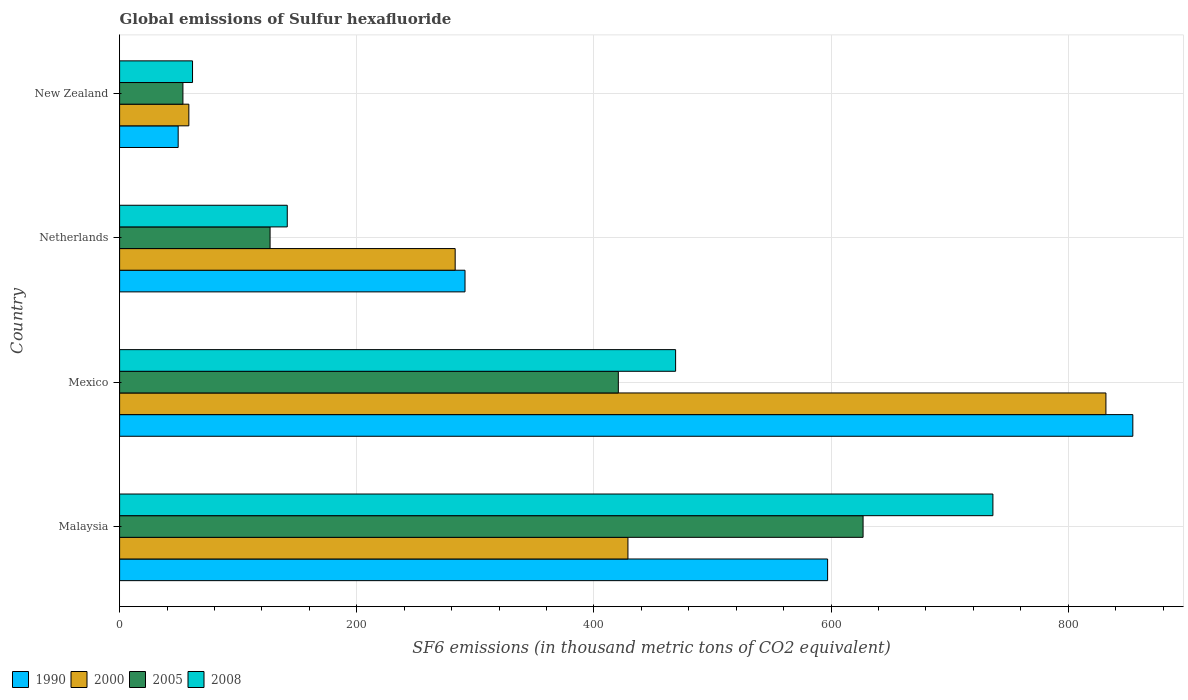How many different coloured bars are there?
Provide a short and direct response. 4. How many groups of bars are there?
Your answer should be compact. 4. How many bars are there on the 3rd tick from the top?
Keep it short and to the point. 4. How many bars are there on the 3rd tick from the bottom?
Keep it short and to the point. 4. What is the label of the 4th group of bars from the top?
Give a very brief answer. Malaysia. What is the global emissions of Sulfur hexafluoride in 1990 in Mexico?
Your answer should be very brief. 854.5. Across all countries, what is the maximum global emissions of Sulfur hexafluoride in 2005?
Your answer should be compact. 627. Across all countries, what is the minimum global emissions of Sulfur hexafluoride in 2008?
Make the answer very short. 61.5. In which country was the global emissions of Sulfur hexafluoride in 2008 maximum?
Your answer should be compact. Malaysia. In which country was the global emissions of Sulfur hexafluoride in 2005 minimum?
Give a very brief answer. New Zealand. What is the total global emissions of Sulfur hexafluoride in 2005 in the graph?
Offer a very short reply. 1227.9. What is the difference between the global emissions of Sulfur hexafluoride in 2008 in Netherlands and that in New Zealand?
Your response must be concise. 79.9. What is the difference between the global emissions of Sulfur hexafluoride in 2005 in Mexico and the global emissions of Sulfur hexafluoride in 2008 in New Zealand?
Provide a short and direct response. 359.1. What is the average global emissions of Sulfur hexafluoride in 1990 per country?
Give a very brief answer. 448.07. What is the difference between the global emissions of Sulfur hexafluoride in 2008 and global emissions of Sulfur hexafluoride in 2000 in Mexico?
Provide a succinct answer. -362.9. In how many countries, is the global emissions of Sulfur hexafluoride in 2000 greater than 280 thousand metric tons?
Your answer should be very brief. 3. What is the ratio of the global emissions of Sulfur hexafluoride in 1990 in Malaysia to that in New Zealand?
Make the answer very short. 12.09. What is the difference between the highest and the second highest global emissions of Sulfur hexafluoride in 1990?
Offer a very short reply. 257.4. What is the difference between the highest and the lowest global emissions of Sulfur hexafluoride in 2008?
Your response must be concise. 675. How many countries are there in the graph?
Ensure brevity in your answer.  4. Are the values on the major ticks of X-axis written in scientific E-notation?
Make the answer very short. No. How many legend labels are there?
Ensure brevity in your answer.  4. What is the title of the graph?
Make the answer very short. Global emissions of Sulfur hexafluoride. What is the label or title of the X-axis?
Offer a terse response. SF6 emissions (in thousand metric tons of CO2 equivalent). What is the label or title of the Y-axis?
Make the answer very short. Country. What is the SF6 emissions (in thousand metric tons of CO2 equivalent) of 1990 in Malaysia?
Give a very brief answer. 597.1. What is the SF6 emissions (in thousand metric tons of CO2 equivalent) of 2000 in Malaysia?
Offer a very short reply. 428.7. What is the SF6 emissions (in thousand metric tons of CO2 equivalent) of 2005 in Malaysia?
Give a very brief answer. 627. What is the SF6 emissions (in thousand metric tons of CO2 equivalent) in 2008 in Malaysia?
Offer a terse response. 736.5. What is the SF6 emissions (in thousand metric tons of CO2 equivalent) of 1990 in Mexico?
Offer a terse response. 854.5. What is the SF6 emissions (in thousand metric tons of CO2 equivalent) in 2000 in Mexico?
Your response must be concise. 831.8. What is the SF6 emissions (in thousand metric tons of CO2 equivalent) of 2005 in Mexico?
Offer a very short reply. 420.6. What is the SF6 emissions (in thousand metric tons of CO2 equivalent) in 2008 in Mexico?
Provide a succinct answer. 468.9. What is the SF6 emissions (in thousand metric tons of CO2 equivalent) in 1990 in Netherlands?
Make the answer very short. 291.3. What is the SF6 emissions (in thousand metric tons of CO2 equivalent) in 2000 in Netherlands?
Your answer should be very brief. 283. What is the SF6 emissions (in thousand metric tons of CO2 equivalent) of 2005 in Netherlands?
Your answer should be very brief. 126.9. What is the SF6 emissions (in thousand metric tons of CO2 equivalent) of 2008 in Netherlands?
Make the answer very short. 141.4. What is the SF6 emissions (in thousand metric tons of CO2 equivalent) of 1990 in New Zealand?
Your response must be concise. 49.4. What is the SF6 emissions (in thousand metric tons of CO2 equivalent) in 2000 in New Zealand?
Offer a very short reply. 58.4. What is the SF6 emissions (in thousand metric tons of CO2 equivalent) in 2005 in New Zealand?
Your answer should be compact. 53.4. What is the SF6 emissions (in thousand metric tons of CO2 equivalent) of 2008 in New Zealand?
Provide a succinct answer. 61.5. Across all countries, what is the maximum SF6 emissions (in thousand metric tons of CO2 equivalent) of 1990?
Offer a very short reply. 854.5. Across all countries, what is the maximum SF6 emissions (in thousand metric tons of CO2 equivalent) in 2000?
Ensure brevity in your answer.  831.8. Across all countries, what is the maximum SF6 emissions (in thousand metric tons of CO2 equivalent) in 2005?
Keep it short and to the point. 627. Across all countries, what is the maximum SF6 emissions (in thousand metric tons of CO2 equivalent) of 2008?
Offer a terse response. 736.5. Across all countries, what is the minimum SF6 emissions (in thousand metric tons of CO2 equivalent) of 1990?
Offer a terse response. 49.4. Across all countries, what is the minimum SF6 emissions (in thousand metric tons of CO2 equivalent) in 2000?
Make the answer very short. 58.4. Across all countries, what is the minimum SF6 emissions (in thousand metric tons of CO2 equivalent) in 2005?
Your answer should be very brief. 53.4. Across all countries, what is the minimum SF6 emissions (in thousand metric tons of CO2 equivalent) of 2008?
Give a very brief answer. 61.5. What is the total SF6 emissions (in thousand metric tons of CO2 equivalent) in 1990 in the graph?
Offer a terse response. 1792.3. What is the total SF6 emissions (in thousand metric tons of CO2 equivalent) in 2000 in the graph?
Your answer should be very brief. 1601.9. What is the total SF6 emissions (in thousand metric tons of CO2 equivalent) in 2005 in the graph?
Ensure brevity in your answer.  1227.9. What is the total SF6 emissions (in thousand metric tons of CO2 equivalent) in 2008 in the graph?
Offer a terse response. 1408.3. What is the difference between the SF6 emissions (in thousand metric tons of CO2 equivalent) of 1990 in Malaysia and that in Mexico?
Ensure brevity in your answer.  -257.4. What is the difference between the SF6 emissions (in thousand metric tons of CO2 equivalent) of 2000 in Malaysia and that in Mexico?
Ensure brevity in your answer.  -403.1. What is the difference between the SF6 emissions (in thousand metric tons of CO2 equivalent) in 2005 in Malaysia and that in Mexico?
Ensure brevity in your answer.  206.4. What is the difference between the SF6 emissions (in thousand metric tons of CO2 equivalent) of 2008 in Malaysia and that in Mexico?
Offer a terse response. 267.6. What is the difference between the SF6 emissions (in thousand metric tons of CO2 equivalent) of 1990 in Malaysia and that in Netherlands?
Offer a terse response. 305.8. What is the difference between the SF6 emissions (in thousand metric tons of CO2 equivalent) of 2000 in Malaysia and that in Netherlands?
Provide a succinct answer. 145.7. What is the difference between the SF6 emissions (in thousand metric tons of CO2 equivalent) in 2005 in Malaysia and that in Netherlands?
Make the answer very short. 500.1. What is the difference between the SF6 emissions (in thousand metric tons of CO2 equivalent) of 2008 in Malaysia and that in Netherlands?
Provide a succinct answer. 595.1. What is the difference between the SF6 emissions (in thousand metric tons of CO2 equivalent) in 1990 in Malaysia and that in New Zealand?
Offer a terse response. 547.7. What is the difference between the SF6 emissions (in thousand metric tons of CO2 equivalent) in 2000 in Malaysia and that in New Zealand?
Give a very brief answer. 370.3. What is the difference between the SF6 emissions (in thousand metric tons of CO2 equivalent) of 2005 in Malaysia and that in New Zealand?
Keep it short and to the point. 573.6. What is the difference between the SF6 emissions (in thousand metric tons of CO2 equivalent) of 2008 in Malaysia and that in New Zealand?
Your answer should be compact. 675. What is the difference between the SF6 emissions (in thousand metric tons of CO2 equivalent) in 1990 in Mexico and that in Netherlands?
Keep it short and to the point. 563.2. What is the difference between the SF6 emissions (in thousand metric tons of CO2 equivalent) of 2000 in Mexico and that in Netherlands?
Keep it short and to the point. 548.8. What is the difference between the SF6 emissions (in thousand metric tons of CO2 equivalent) of 2005 in Mexico and that in Netherlands?
Provide a succinct answer. 293.7. What is the difference between the SF6 emissions (in thousand metric tons of CO2 equivalent) in 2008 in Mexico and that in Netherlands?
Provide a succinct answer. 327.5. What is the difference between the SF6 emissions (in thousand metric tons of CO2 equivalent) of 1990 in Mexico and that in New Zealand?
Your response must be concise. 805.1. What is the difference between the SF6 emissions (in thousand metric tons of CO2 equivalent) of 2000 in Mexico and that in New Zealand?
Give a very brief answer. 773.4. What is the difference between the SF6 emissions (in thousand metric tons of CO2 equivalent) in 2005 in Mexico and that in New Zealand?
Your answer should be very brief. 367.2. What is the difference between the SF6 emissions (in thousand metric tons of CO2 equivalent) of 2008 in Mexico and that in New Zealand?
Your answer should be very brief. 407.4. What is the difference between the SF6 emissions (in thousand metric tons of CO2 equivalent) in 1990 in Netherlands and that in New Zealand?
Provide a succinct answer. 241.9. What is the difference between the SF6 emissions (in thousand metric tons of CO2 equivalent) of 2000 in Netherlands and that in New Zealand?
Your answer should be compact. 224.6. What is the difference between the SF6 emissions (in thousand metric tons of CO2 equivalent) of 2005 in Netherlands and that in New Zealand?
Provide a short and direct response. 73.5. What is the difference between the SF6 emissions (in thousand metric tons of CO2 equivalent) in 2008 in Netherlands and that in New Zealand?
Provide a short and direct response. 79.9. What is the difference between the SF6 emissions (in thousand metric tons of CO2 equivalent) of 1990 in Malaysia and the SF6 emissions (in thousand metric tons of CO2 equivalent) of 2000 in Mexico?
Make the answer very short. -234.7. What is the difference between the SF6 emissions (in thousand metric tons of CO2 equivalent) in 1990 in Malaysia and the SF6 emissions (in thousand metric tons of CO2 equivalent) in 2005 in Mexico?
Your answer should be compact. 176.5. What is the difference between the SF6 emissions (in thousand metric tons of CO2 equivalent) of 1990 in Malaysia and the SF6 emissions (in thousand metric tons of CO2 equivalent) of 2008 in Mexico?
Your response must be concise. 128.2. What is the difference between the SF6 emissions (in thousand metric tons of CO2 equivalent) of 2000 in Malaysia and the SF6 emissions (in thousand metric tons of CO2 equivalent) of 2005 in Mexico?
Your answer should be very brief. 8.1. What is the difference between the SF6 emissions (in thousand metric tons of CO2 equivalent) of 2000 in Malaysia and the SF6 emissions (in thousand metric tons of CO2 equivalent) of 2008 in Mexico?
Your answer should be very brief. -40.2. What is the difference between the SF6 emissions (in thousand metric tons of CO2 equivalent) in 2005 in Malaysia and the SF6 emissions (in thousand metric tons of CO2 equivalent) in 2008 in Mexico?
Keep it short and to the point. 158.1. What is the difference between the SF6 emissions (in thousand metric tons of CO2 equivalent) in 1990 in Malaysia and the SF6 emissions (in thousand metric tons of CO2 equivalent) in 2000 in Netherlands?
Make the answer very short. 314.1. What is the difference between the SF6 emissions (in thousand metric tons of CO2 equivalent) of 1990 in Malaysia and the SF6 emissions (in thousand metric tons of CO2 equivalent) of 2005 in Netherlands?
Offer a very short reply. 470.2. What is the difference between the SF6 emissions (in thousand metric tons of CO2 equivalent) of 1990 in Malaysia and the SF6 emissions (in thousand metric tons of CO2 equivalent) of 2008 in Netherlands?
Ensure brevity in your answer.  455.7. What is the difference between the SF6 emissions (in thousand metric tons of CO2 equivalent) of 2000 in Malaysia and the SF6 emissions (in thousand metric tons of CO2 equivalent) of 2005 in Netherlands?
Make the answer very short. 301.8. What is the difference between the SF6 emissions (in thousand metric tons of CO2 equivalent) of 2000 in Malaysia and the SF6 emissions (in thousand metric tons of CO2 equivalent) of 2008 in Netherlands?
Give a very brief answer. 287.3. What is the difference between the SF6 emissions (in thousand metric tons of CO2 equivalent) of 2005 in Malaysia and the SF6 emissions (in thousand metric tons of CO2 equivalent) of 2008 in Netherlands?
Make the answer very short. 485.6. What is the difference between the SF6 emissions (in thousand metric tons of CO2 equivalent) in 1990 in Malaysia and the SF6 emissions (in thousand metric tons of CO2 equivalent) in 2000 in New Zealand?
Give a very brief answer. 538.7. What is the difference between the SF6 emissions (in thousand metric tons of CO2 equivalent) of 1990 in Malaysia and the SF6 emissions (in thousand metric tons of CO2 equivalent) of 2005 in New Zealand?
Give a very brief answer. 543.7. What is the difference between the SF6 emissions (in thousand metric tons of CO2 equivalent) in 1990 in Malaysia and the SF6 emissions (in thousand metric tons of CO2 equivalent) in 2008 in New Zealand?
Ensure brevity in your answer.  535.6. What is the difference between the SF6 emissions (in thousand metric tons of CO2 equivalent) in 2000 in Malaysia and the SF6 emissions (in thousand metric tons of CO2 equivalent) in 2005 in New Zealand?
Ensure brevity in your answer.  375.3. What is the difference between the SF6 emissions (in thousand metric tons of CO2 equivalent) in 2000 in Malaysia and the SF6 emissions (in thousand metric tons of CO2 equivalent) in 2008 in New Zealand?
Provide a succinct answer. 367.2. What is the difference between the SF6 emissions (in thousand metric tons of CO2 equivalent) of 2005 in Malaysia and the SF6 emissions (in thousand metric tons of CO2 equivalent) of 2008 in New Zealand?
Keep it short and to the point. 565.5. What is the difference between the SF6 emissions (in thousand metric tons of CO2 equivalent) of 1990 in Mexico and the SF6 emissions (in thousand metric tons of CO2 equivalent) of 2000 in Netherlands?
Your answer should be compact. 571.5. What is the difference between the SF6 emissions (in thousand metric tons of CO2 equivalent) of 1990 in Mexico and the SF6 emissions (in thousand metric tons of CO2 equivalent) of 2005 in Netherlands?
Your answer should be very brief. 727.6. What is the difference between the SF6 emissions (in thousand metric tons of CO2 equivalent) in 1990 in Mexico and the SF6 emissions (in thousand metric tons of CO2 equivalent) in 2008 in Netherlands?
Provide a short and direct response. 713.1. What is the difference between the SF6 emissions (in thousand metric tons of CO2 equivalent) of 2000 in Mexico and the SF6 emissions (in thousand metric tons of CO2 equivalent) of 2005 in Netherlands?
Provide a succinct answer. 704.9. What is the difference between the SF6 emissions (in thousand metric tons of CO2 equivalent) in 2000 in Mexico and the SF6 emissions (in thousand metric tons of CO2 equivalent) in 2008 in Netherlands?
Provide a short and direct response. 690.4. What is the difference between the SF6 emissions (in thousand metric tons of CO2 equivalent) of 2005 in Mexico and the SF6 emissions (in thousand metric tons of CO2 equivalent) of 2008 in Netherlands?
Offer a very short reply. 279.2. What is the difference between the SF6 emissions (in thousand metric tons of CO2 equivalent) of 1990 in Mexico and the SF6 emissions (in thousand metric tons of CO2 equivalent) of 2000 in New Zealand?
Provide a succinct answer. 796.1. What is the difference between the SF6 emissions (in thousand metric tons of CO2 equivalent) of 1990 in Mexico and the SF6 emissions (in thousand metric tons of CO2 equivalent) of 2005 in New Zealand?
Make the answer very short. 801.1. What is the difference between the SF6 emissions (in thousand metric tons of CO2 equivalent) in 1990 in Mexico and the SF6 emissions (in thousand metric tons of CO2 equivalent) in 2008 in New Zealand?
Your answer should be very brief. 793. What is the difference between the SF6 emissions (in thousand metric tons of CO2 equivalent) of 2000 in Mexico and the SF6 emissions (in thousand metric tons of CO2 equivalent) of 2005 in New Zealand?
Give a very brief answer. 778.4. What is the difference between the SF6 emissions (in thousand metric tons of CO2 equivalent) in 2000 in Mexico and the SF6 emissions (in thousand metric tons of CO2 equivalent) in 2008 in New Zealand?
Offer a very short reply. 770.3. What is the difference between the SF6 emissions (in thousand metric tons of CO2 equivalent) of 2005 in Mexico and the SF6 emissions (in thousand metric tons of CO2 equivalent) of 2008 in New Zealand?
Offer a terse response. 359.1. What is the difference between the SF6 emissions (in thousand metric tons of CO2 equivalent) of 1990 in Netherlands and the SF6 emissions (in thousand metric tons of CO2 equivalent) of 2000 in New Zealand?
Ensure brevity in your answer.  232.9. What is the difference between the SF6 emissions (in thousand metric tons of CO2 equivalent) in 1990 in Netherlands and the SF6 emissions (in thousand metric tons of CO2 equivalent) in 2005 in New Zealand?
Offer a terse response. 237.9. What is the difference between the SF6 emissions (in thousand metric tons of CO2 equivalent) of 1990 in Netherlands and the SF6 emissions (in thousand metric tons of CO2 equivalent) of 2008 in New Zealand?
Keep it short and to the point. 229.8. What is the difference between the SF6 emissions (in thousand metric tons of CO2 equivalent) in 2000 in Netherlands and the SF6 emissions (in thousand metric tons of CO2 equivalent) in 2005 in New Zealand?
Keep it short and to the point. 229.6. What is the difference between the SF6 emissions (in thousand metric tons of CO2 equivalent) in 2000 in Netherlands and the SF6 emissions (in thousand metric tons of CO2 equivalent) in 2008 in New Zealand?
Provide a succinct answer. 221.5. What is the difference between the SF6 emissions (in thousand metric tons of CO2 equivalent) in 2005 in Netherlands and the SF6 emissions (in thousand metric tons of CO2 equivalent) in 2008 in New Zealand?
Make the answer very short. 65.4. What is the average SF6 emissions (in thousand metric tons of CO2 equivalent) of 1990 per country?
Keep it short and to the point. 448.07. What is the average SF6 emissions (in thousand metric tons of CO2 equivalent) of 2000 per country?
Provide a succinct answer. 400.48. What is the average SF6 emissions (in thousand metric tons of CO2 equivalent) of 2005 per country?
Provide a succinct answer. 306.98. What is the average SF6 emissions (in thousand metric tons of CO2 equivalent) in 2008 per country?
Your response must be concise. 352.07. What is the difference between the SF6 emissions (in thousand metric tons of CO2 equivalent) in 1990 and SF6 emissions (in thousand metric tons of CO2 equivalent) in 2000 in Malaysia?
Provide a succinct answer. 168.4. What is the difference between the SF6 emissions (in thousand metric tons of CO2 equivalent) in 1990 and SF6 emissions (in thousand metric tons of CO2 equivalent) in 2005 in Malaysia?
Offer a terse response. -29.9. What is the difference between the SF6 emissions (in thousand metric tons of CO2 equivalent) in 1990 and SF6 emissions (in thousand metric tons of CO2 equivalent) in 2008 in Malaysia?
Your answer should be very brief. -139.4. What is the difference between the SF6 emissions (in thousand metric tons of CO2 equivalent) of 2000 and SF6 emissions (in thousand metric tons of CO2 equivalent) of 2005 in Malaysia?
Keep it short and to the point. -198.3. What is the difference between the SF6 emissions (in thousand metric tons of CO2 equivalent) of 2000 and SF6 emissions (in thousand metric tons of CO2 equivalent) of 2008 in Malaysia?
Ensure brevity in your answer.  -307.8. What is the difference between the SF6 emissions (in thousand metric tons of CO2 equivalent) of 2005 and SF6 emissions (in thousand metric tons of CO2 equivalent) of 2008 in Malaysia?
Your answer should be very brief. -109.5. What is the difference between the SF6 emissions (in thousand metric tons of CO2 equivalent) of 1990 and SF6 emissions (in thousand metric tons of CO2 equivalent) of 2000 in Mexico?
Make the answer very short. 22.7. What is the difference between the SF6 emissions (in thousand metric tons of CO2 equivalent) in 1990 and SF6 emissions (in thousand metric tons of CO2 equivalent) in 2005 in Mexico?
Offer a very short reply. 433.9. What is the difference between the SF6 emissions (in thousand metric tons of CO2 equivalent) of 1990 and SF6 emissions (in thousand metric tons of CO2 equivalent) of 2008 in Mexico?
Ensure brevity in your answer.  385.6. What is the difference between the SF6 emissions (in thousand metric tons of CO2 equivalent) of 2000 and SF6 emissions (in thousand metric tons of CO2 equivalent) of 2005 in Mexico?
Make the answer very short. 411.2. What is the difference between the SF6 emissions (in thousand metric tons of CO2 equivalent) in 2000 and SF6 emissions (in thousand metric tons of CO2 equivalent) in 2008 in Mexico?
Your answer should be very brief. 362.9. What is the difference between the SF6 emissions (in thousand metric tons of CO2 equivalent) of 2005 and SF6 emissions (in thousand metric tons of CO2 equivalent) of 2008 in Mexico?
Provide a short and direct response. -48.3. What is the difference between the SF6 emissions (in thousand metric tons of CO2 equivalent) in 1990 and SF6 emissions (in thousand metric tons of CO2 equivalent) in 2005 in Netherlands?
Keep it short and to the point. 164.4. What is the difference between the SF6 emissions (in thousand metric tons of CO2 equivalent) of 1990 and SF6 emissions (in thousand metric tons of CO2 equivalent) of 2008 in Netherlands?
Give a very brief answer. 149.9. What is the difference between the SF6 emissions (in thousand metric tons of CO2 equivalent) of 2000 and SF6 emissions (in thousand metric tons of CO2 equivalent) of 2005 in Netherlands?
Keep it short and to the point. 156.1. What is the difference between the SF6 emissions (in thousand metric tons of CO2 equivalent) of 2000 and SF6 emissions (in thousand metric tons of CO2 equivalent) of 2008 in Netherlands?
Offer a terse response. 141.6. What is the difference between the SF6 emissions (in thousand metric tons of CO2 equivalent) of 2005 and SF6 emissions (in thousand metric tons of CO2 equivalent) of 2008 in Netherlands?
Offer a terse response. -14.5. What is the difference between the SF6 emissions (in thousand metric tons of CO2 equivalent) of 1990 and SF6 emissions (in thousand metric tons of CO2 equivalent) of 2005 in New Zealand?
Your answer should be very brief. -4. What is the difference between the SF6 emissions (in thousand metric tons of CO2 equivalent) of 1990 and SF6 emissions (in thousand metric tons of CO2 equivalent) of 2008 in New Zealand?
Your response must be concise. -12.1. What is the difference between the SF6 emissions (in thousand metric tons of CO2 equivalent) in 2005 and SF6 emissions (in thousand metric tons of CO2 equivalent) in 2008 in New Zealand?
Give a very brief answer. -8.1. What is the ratio of the SF6 emissions (in thousand metric tons of CO2 equivalent) of 1990 in Malaysia to that in Mexico?
Keep it short and to the point. 0.7. What is the ratio of the SF6 emissions (in thousand metric tons of CO2 equivalent) in 2000 in Malaysia to that in Mexico?
Your answer should be very brief. 0.52. What is the ratio of the SF6 emissions (in thousand metric tons of CO2 equivalent) of 2005 in Malaysia to that in Mexico?
Provide a short and direct response. 1.49. What is the ratio of the SF6 emissions (in thousand metric tons of CO2 equivalent) of 2008 in Malaysia to that in Mexico?
Offer a terse response. 1.57. What is the ratio of the SF6 emissions (in thousand metric tons of CO2 equivalent) of 1990 in Malaysia to that in Netherlands?
Ensure brevity in your answer.  2.05. What is the ratio of the SF6 emissions (in thousand metric tons of CO2 equivalent) of 2000 in Malaysia to that in Netherlands?
Provide a succinct answer. 1.51. What is the ratio of the SF6 emissions (in thousand metric tons of CO2 equivalent) of 2005 in Malaysia to that in Netherlands?
Offer a very short reply. 4.94. What is the ratio of the SF6 emissions (in thousand metric tons of CO2 equivalent) of 2008 in Malaysia to that in Netherlands?
Provide a short and direct response. 5.21. What is the ratio of the SF6 emissions (in thousand metric tons of CO2 equivalent) of 1990 in Malaysia to that in New Zealand?
Keep it short and to the point. 12.09. What is the ratio of the SF6 emissions (in thousand metric tons of CO2 equivalent) in 2000 in Malaysia to that in New Zealand?
Give a very brief answer. 7.34. What is the ratio of the SF6 emissions (in thousand metric tons of CO2 equivalent) in 2005 in Malaysia to that in New Zealand?
Make the answer very short. 11.74. What is the ratio of the SF6 emissions (in thousand metric tons of CO2 equivalent) of 2008 in Malaysia to that in New Zealand?
Make the answer very short. 11.98. What is the ratio of the SF6 emissions (in thousand metric tons of CO2 equivalent) of 1990 in Mexico to that in Netherlands?
Offer a terse response. 2.93. What is the ratio of the SF6 emissions (in thousand metric tons of CO2 equivalent) of 2000 in Mexico to that in Netherlands?
Make the answer very short. 2.94. What is the ratio of the SF6 emissions (in thousand metric tons of CO2 equivalent) in 2005 in Mexico to that in Netherlands?
Make the answer very short. 3.31. What is the ratio of the SF6 emissions (in thousand metric tons of CO2 equivalent) of 2008 in Mexico to that in Netherlands?
Your answer should be very brief. 3.32. What is the ratio of the SF6 emissions (in thousand metric tons of CO2 equivalent) in 1990 in Mexico to that in New Zealand?
Ensure brevity in your answer.  17.3. What is the ratio of the SF6 emissions (in thousand metric tons of CO2 equivalent) of 2000 in Mexico to that in New Zealand?
Make the answer very short. 14.24. What is the ratio of the SF6 emissions (in thousand metric tons of CO2 equivalent) of 2005 in Mexico to that in New Zealand?
Offer a terse response. 7.88. What is the ratio of the SF6 emissions (in thousand metric tons of CO2 equivalent) in 2008 in Mexico to that in New Zealand?
Offer a very short reply. 7.62. What is the ratio of the SF6 emissions (in thousand metric tons of CO2 equivalent) of 1990 in Netherlands to that in New Zealand?
Keep it short and to the point. 5.9. What is the ratio of the SF6 emissions (in thousand metric tons of CO2 equivalent) in 2000 in Netherlands to that in New Zealand?
Provide a short and direct response. 4.85. What is the ratio of the SF6 emissions (in thousand metric tons of CO2 equivalent) in 2005 in Netherlands to that in New Zealand?
Give a very brief answer. 2.38. What is the ratio of the SF6 emissions (in thousand metric tons of CO2 equivalent) in 2008 in Netherlands to that in New Zealand?
Your answer should be very brief. 2.3. What is the difference between the highest and the second highest SF6 emissions (in thousand metric tons of CO2 equivalent) of 1990?
Give a very brief answer. 257.4. What is the difference between the highest and the second highest SF6 emissions (in thousand metric tons of CO2 equivalent) in 2000?
Offer a very short reply. 403.1. What is the difference between the highest and the second highest SF6 emissions (in thousand metric tons of CO2 equivalent) in 2005?
Keep it short and to the point. 206.4. What is the difference between the highest and the second highest SF6 emissions (in thousand metric tons of CO2 equivalent) in 2008?
Offer a very short reply. 267.6. What is the difference between the highest and the lowest SF6 emissions (in thousand metric tons of CO2 equivalent) in 1990?
Your answer should be very brief. 805.1. What is the difference between the highest and the lowest SF6 emissions (in thousand metric tons of CO2 equivalent) of 2000?
Offer a terse response. 773.4. What is the difference between the highest and the lowest SF6 emissions (in thousand metric tons of CO2 equivalent) of 2005?
Your response must be concise. 573.6. What is the difference between the highest and the lowest SF6 emissions (in thousand metric tons of CO2 equivalent) in 2008?
Give a very brief answer. 675. 